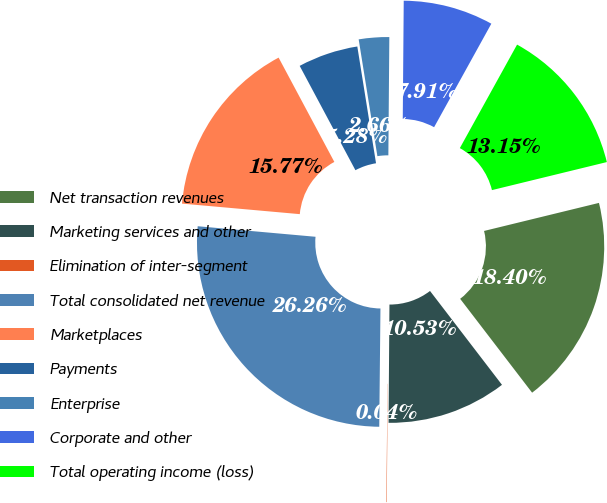Convert chart to OTSL. <chart><loc_0><loc_0><loc_500><loc_500><pie_chart><fcel>Net transaction revenues<fcel>Marketing services and other<fcel>Elimination of inter-segment<fcel>Total consolidated net revenue<fcel>Marketplaces<fcel>Payments<fcel>Enterprise<fcel>Corporate and other<fcel>Total operating income (loss)<nl><fcel>18.4%<fcel>10.53%<fcel>0.04%<fcel>26.26%<fcel>15.77%<fcel>5.28%<fcel>2.66%<fcel>7.91%<fcel>13.15%<nl></chart> 